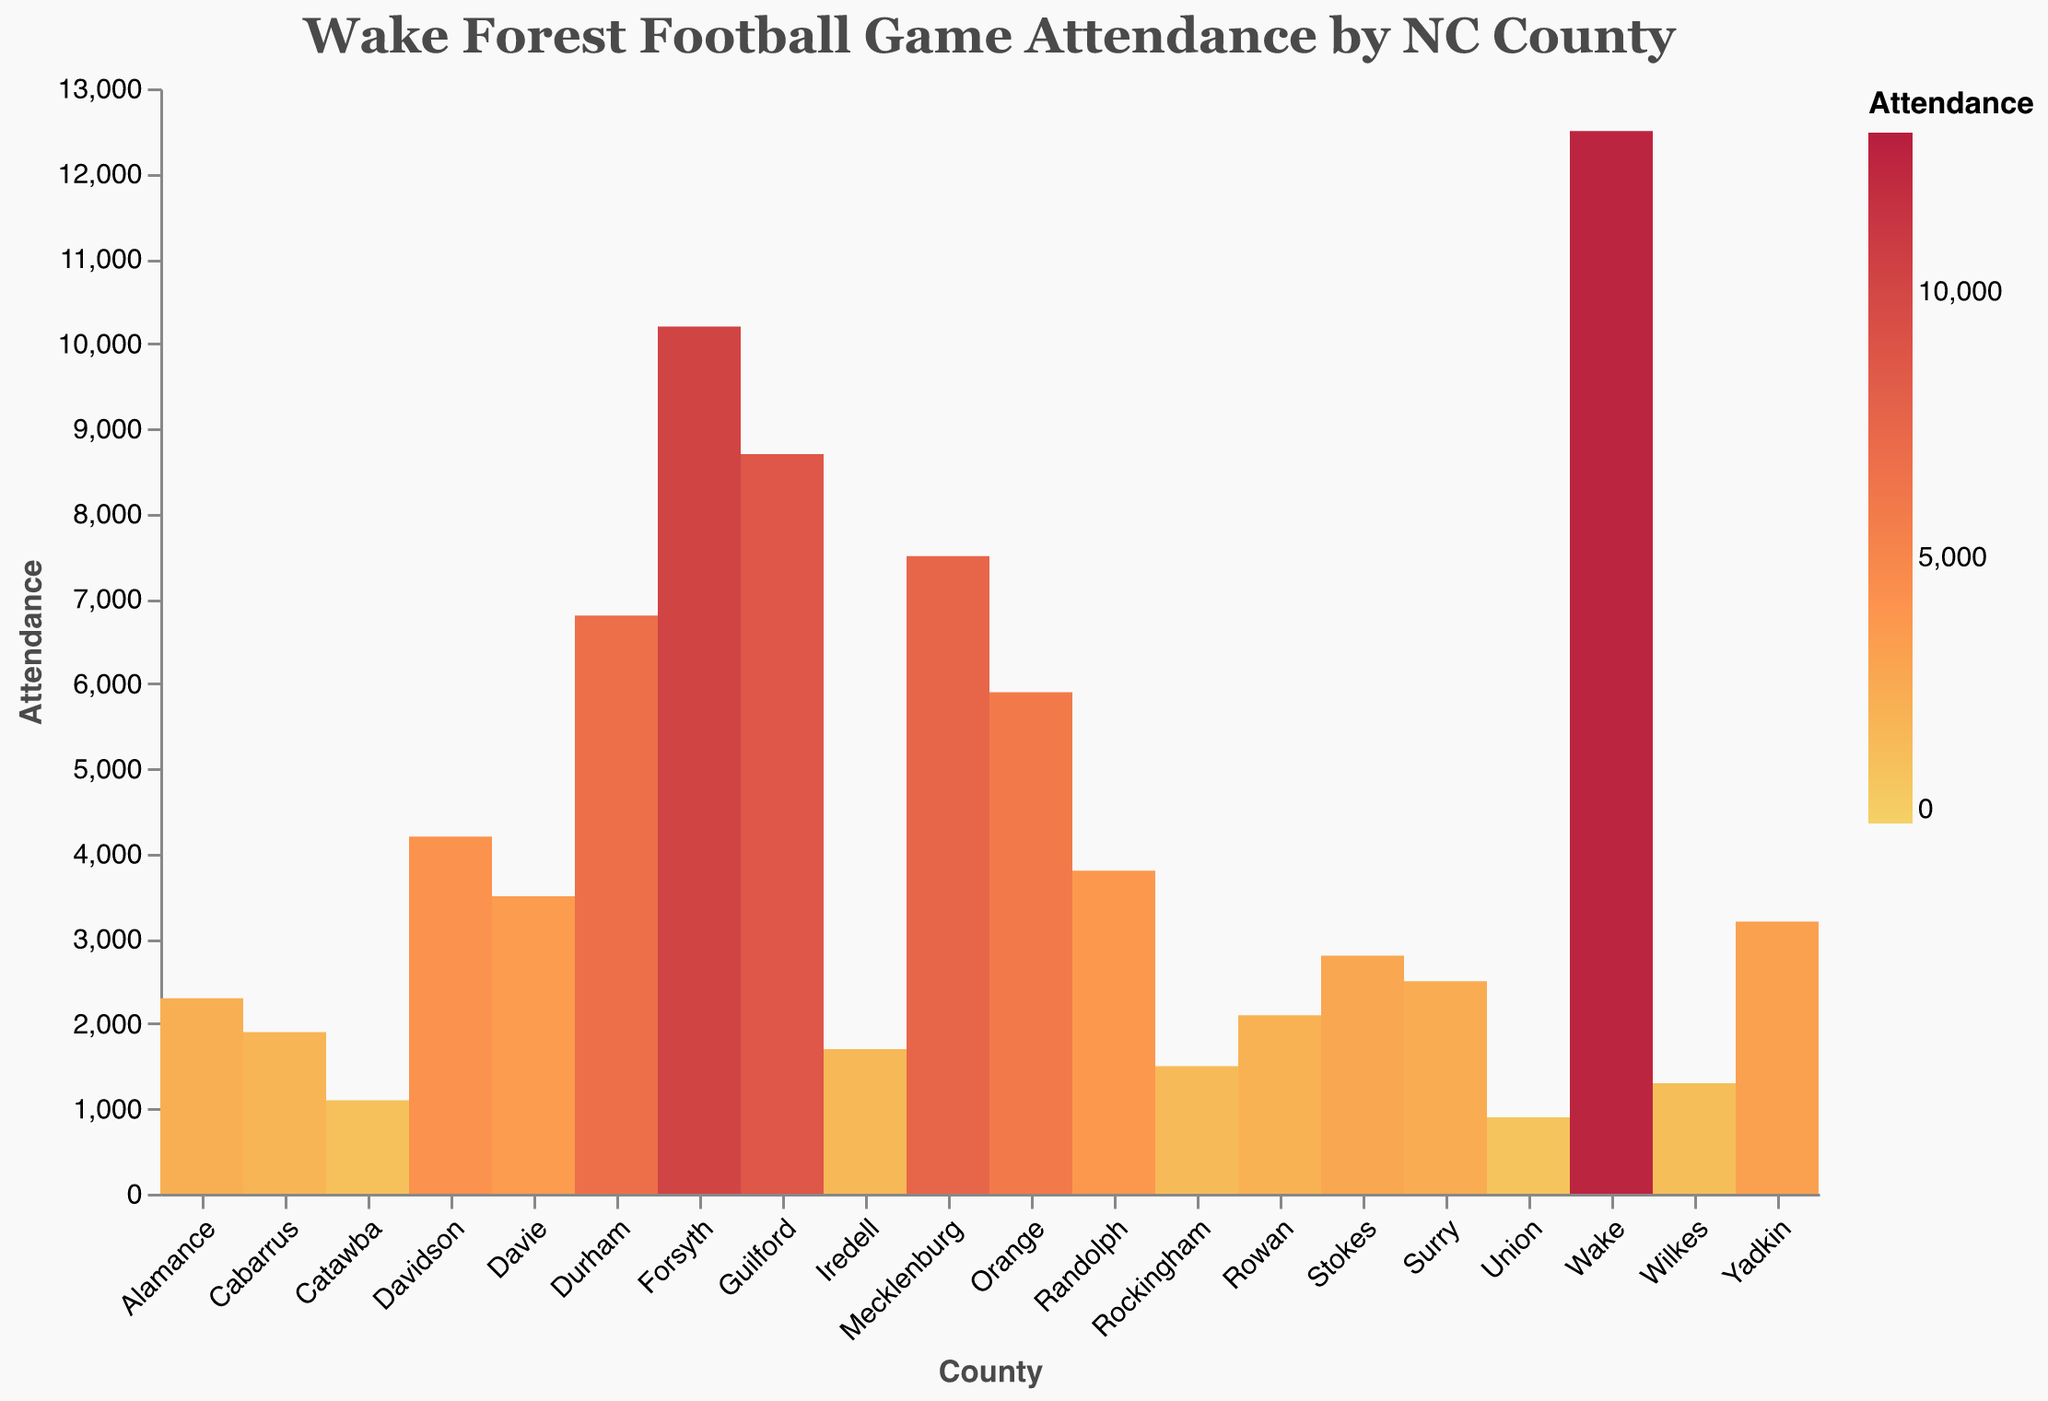What is the title of the figure? The title is located at the top of the figure and provides a descriptive heading.
Answer: Wake Forest Football Game Attendance by NC County How many counties are represented in the figure? Count the number of distinct counties listed along the x-axis.
Answer: 20 Which county has the highest football game attendance? Identify the county with the highest bar along the y-axis.
Answer: Wake What is the attendance for Forsyth County? Locate Forsyth on the x-axis and check the corresponding y-axis value.
Answer: 10,200 Which county has the lowest attendance? Identify the county with the smallest bar along the y-axis.
Answer: Union What is the difference in attendance between Wake and Mecklenburg counties? Find the attendance values for both counties and subtract the smaller from the larger one: 12500 (Wake) - 7500 (Mecklenburg).
Answer: 5,000 How does the attendance in Durham compare to that of Orange County? Determine the attendance values for both counties and compare them: 6,800 (Durham) and 5,900 (Orange).
Answer: Durham has more attendance than Orange What is the average attendance across all counties? Sum the attendance values for all counties and divide by the number of counties: (12500 + 10200 + ... + 900)/20.
Answer: 5,945 What color is used to represent the highest attendance? Refer to the color legend that shows attendance and find the color corresponding to the highest range.
Answer: A shade of red Which three counties have the closest attendance figures? Look for counties with attendance values that are numerically close to each other: Randolph (3800), Davie (3500), and Yadkin (3200) have close values.
Answer: Randolph, Davie, Yadkin 